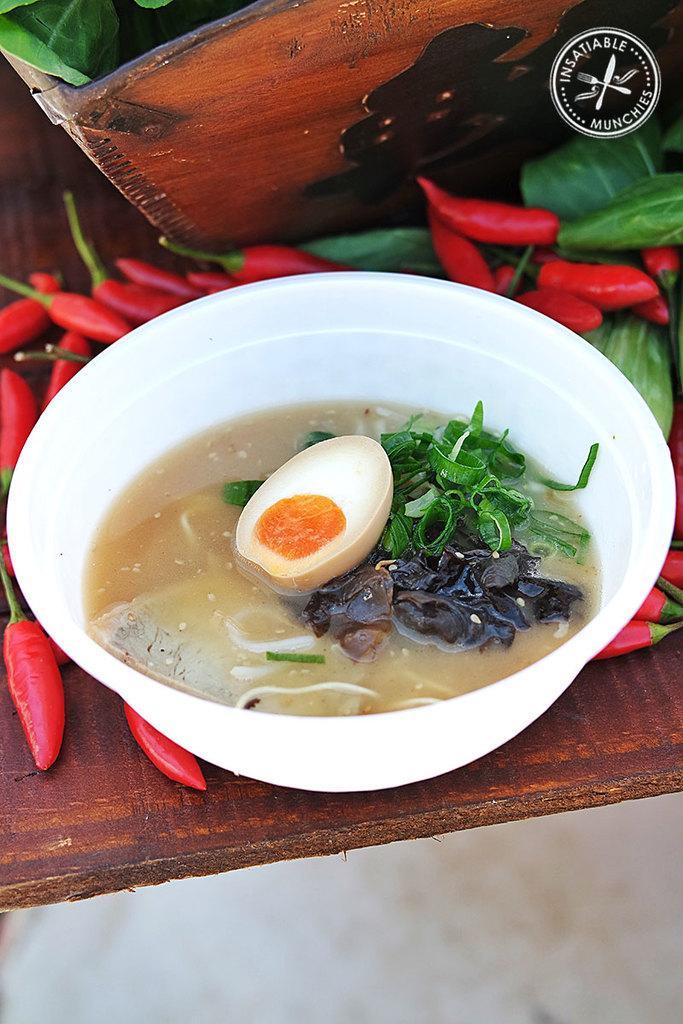Can you describe this image briefly? In this image I can see food is inside the white color bowl. We can see red chilies and green color leaves on the brown color table. 